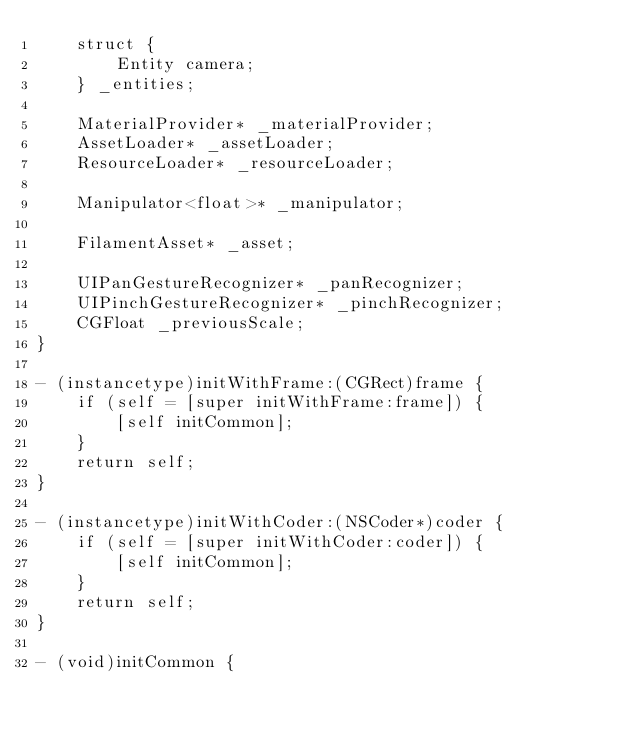<code> <loc_0><loc_0><loc_500><loc_500><_ObjectiveC_>    struct {
        Entity camera;
    } _entities;

    MaterialProvider* _materialProvider;
    AssetLoader* _assetLoader;
    ResourceLoader* _resourceLoader;

    Manipulator<float>* _manipulator;

    FilamentAsset* _asset;

    UIPanGestureRecognizer* _panRecognizer;
    UIPinchGestureRecognizer* _pinchRecognizer;
    CGFloat _previousScale;
}

- (instancetype)initWithFrame:(CGRect)frame {
    if (self = [super initWithFrame:frame]) {
        [self initCommon];
    }
    return self;
}

- (instancetype)initWithCoder:(NSCoder*)coder {
    if (self = [super initWithCoder:coder]) {
        [self initCommon];
    }
    return self;
}

- (void)initCommon {</code> 